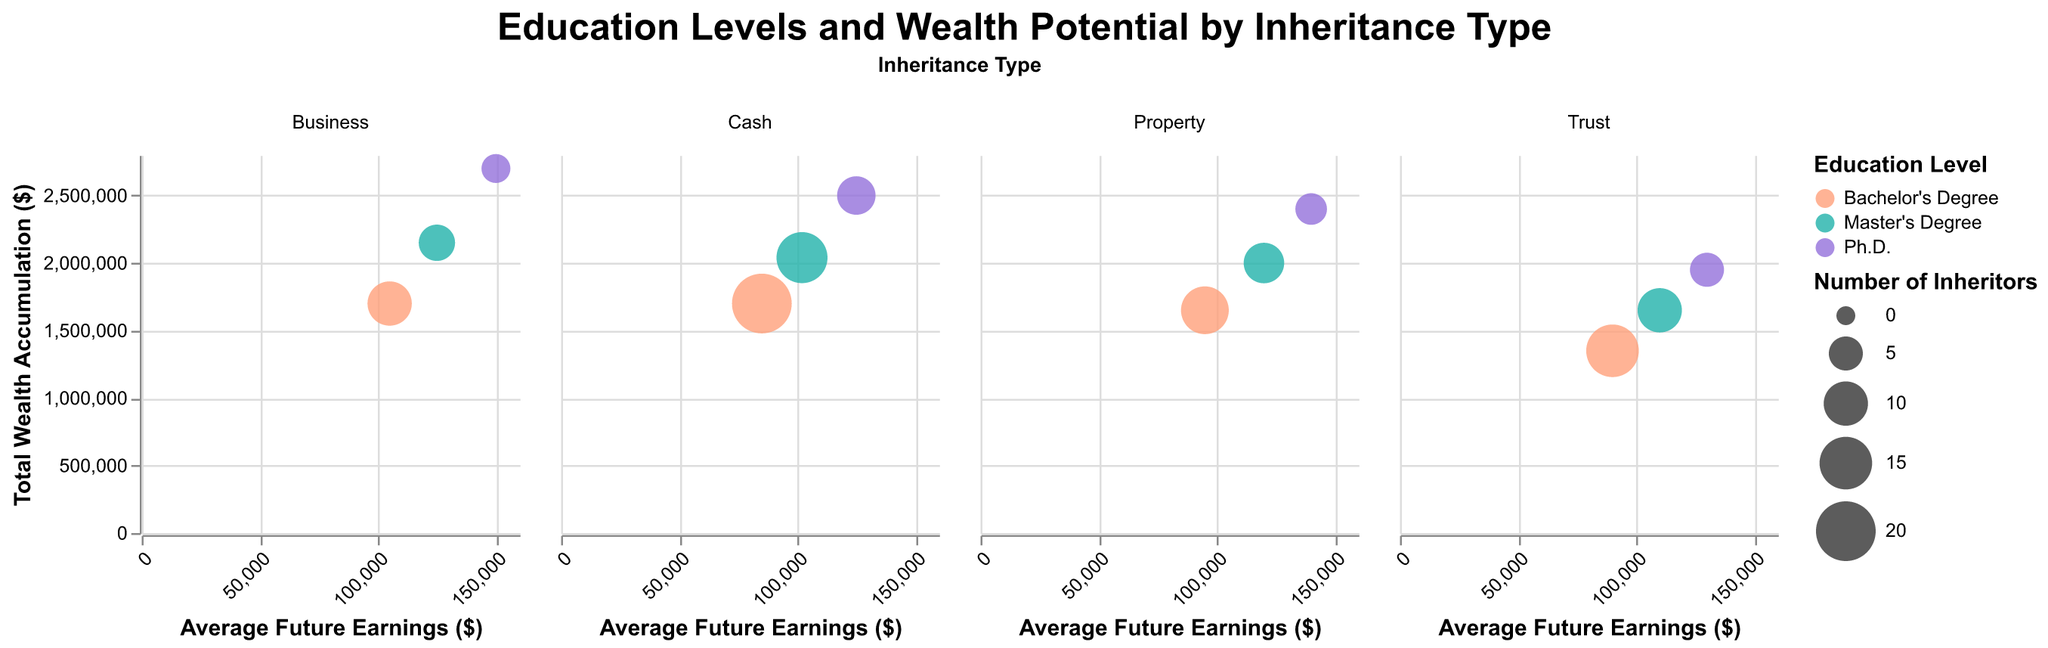What is the relationship between Average Future Earnings and Education Level for inheritors with a Trust? To find the relationship, look at the bubbles in the "Trust" column. Notice the bubbles at different positions on the x-axis marked "Average Future Earnings ($)" and colored by education level. Higher education levels (Ph.D.) correspond to higher Average Future Earnings.
Answer: Higher education levels lead to higher Average Future Earnings for inheritors with a Trust Which inheritance type has the highest Total Wealth Accumulation for Ph.D. holders? Compare the y-axis positions of the Ph.D. bubbles across all inheritance types ("Trust", "Property", "Business", "Cash"). The highest position on the y-axis (indicating Total Wealth Accumulation) for a Ph.D. holder is under "Business".
Answer: Business How many Ph.D. inheritors are there in total? Sum the "Count" of Ph.D. inheritors across all inheritance types. Trust has 5, Property has 4, Business has 3, and Cash has 7. Adding these totals gives 5 + 4 + 3 + 7 = 19.
Answer: 19 Which education level has the highest Total Wealth Accumulation in the Property inheritance type? Look at the Property column and check the y-axis positions of bubbles with different education levels (color-coded). The highest y-axis position corresponds to Ph.D.
Answer: Ph.D What is the size of the bubble representing Bachelor’s Degree inheritors with Cash as the inheritance type? Find the bubble in the Cash column colored for Bachelor’s Degree. The size relates to the "Count" of inheritors. For Cash, Bachelor's Degree has 20 inheritors.
Answer: 20 Which inheritance type shows the largest difference in Average Future Earnings between Master’s Degree and Ph.D. holders? Compare the difference in x-axis (Average Future Earnings) positions between Master’s Degree and Ph.D. holders within each inheritance column. Business has $25,000 difference ($150,000 - $125,000), which is the largest compared to other types.
Answer: Business Do Bachelor's Degree holders generally have higher Total Wealth Accumulation than Master's Degree holders across inheritance types? Compare the y-axis positions of the Bachelor's Degree and Master's Degree bubbles across all columns. In all inheritance types except Property, Master's Degree holders have higher Total Wealth Accumulation.
Answer: No Which inheritance type has the largest bubble, and what does it represent? Find the column with the largest bubble (by size). Check the tooltip or legend for details. The largest bubble is in the Cash column, representing Bachelor’s Degree holders with a count of 20.
Answer: Cash, Bachelor’s Degree, 20 How does the Total Wealth Accumulation compare between using Property and Business for Ph.D. holders? Compare the y-axis positions of Ph.D. bubbles in Property and Business columns. Business has $2,700,000, while Property has $2,400,000.
Answer: Business has $300,000 more than Property 